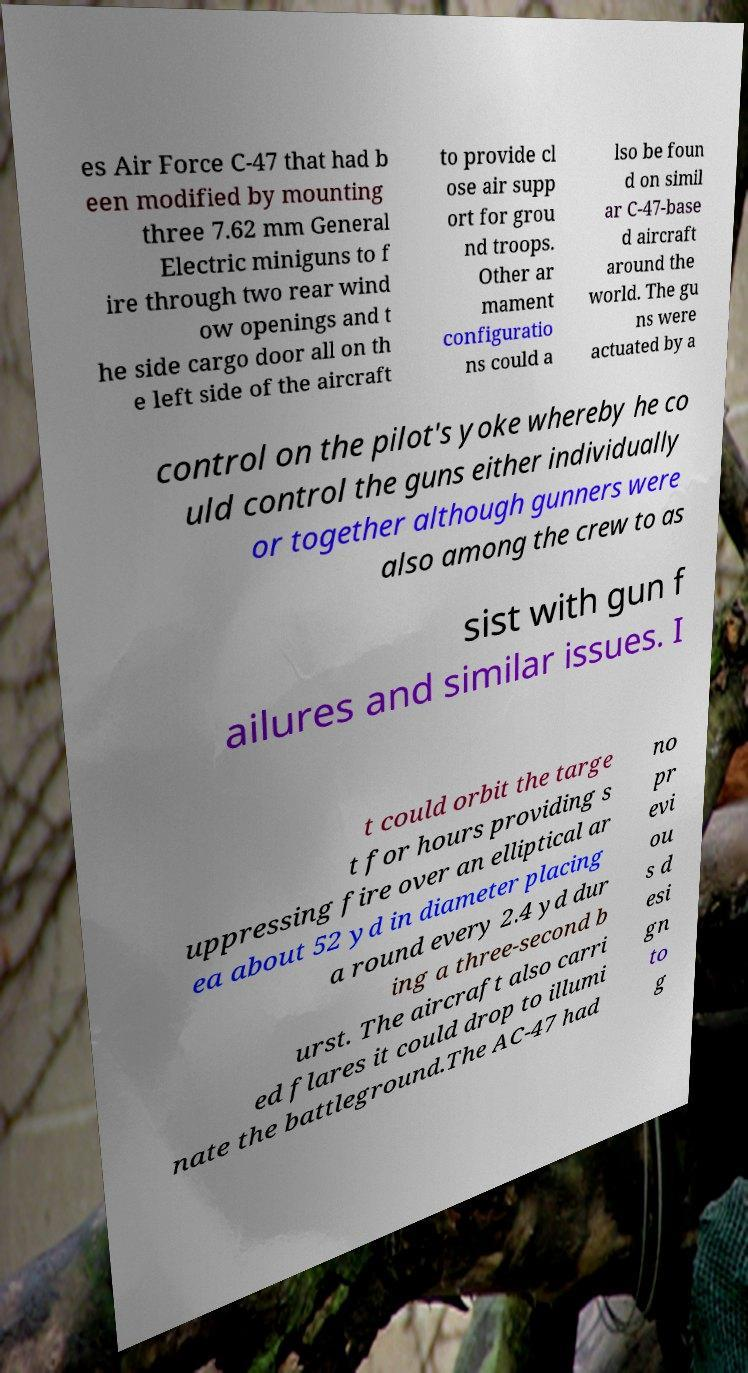Could you assist in decoding the text presented in this image and type it out clearly? es Air Force C-47 that had b een modified by mounting three 7.62 mm General Electric miniguns to f ire through two rear wind ow openings and t he side cargo door all on th e left side of the aircraft to provide cl ose air supp ort for grou nd troops. Other ar mament configuratio ns could a lso be foun d on simil ar C-47-base d aircraft around the world. The gu ns were actuated by a control on the pilot's yoke whereby he co uld control the guns either individually or together although gunners were also among the crew to as sist with gun f ailures and similar issues. I t could orbit the targe t for hours providing s uppressing fire over an elliptical ar ea about 52 yd in diameter placing a round every 2.4 yd dur ing a three-second b urst. The aircraft also carri ed flares it could drop to illumi nate the battleground.The AC-47 had no pr evi ou s d esi gn to g 